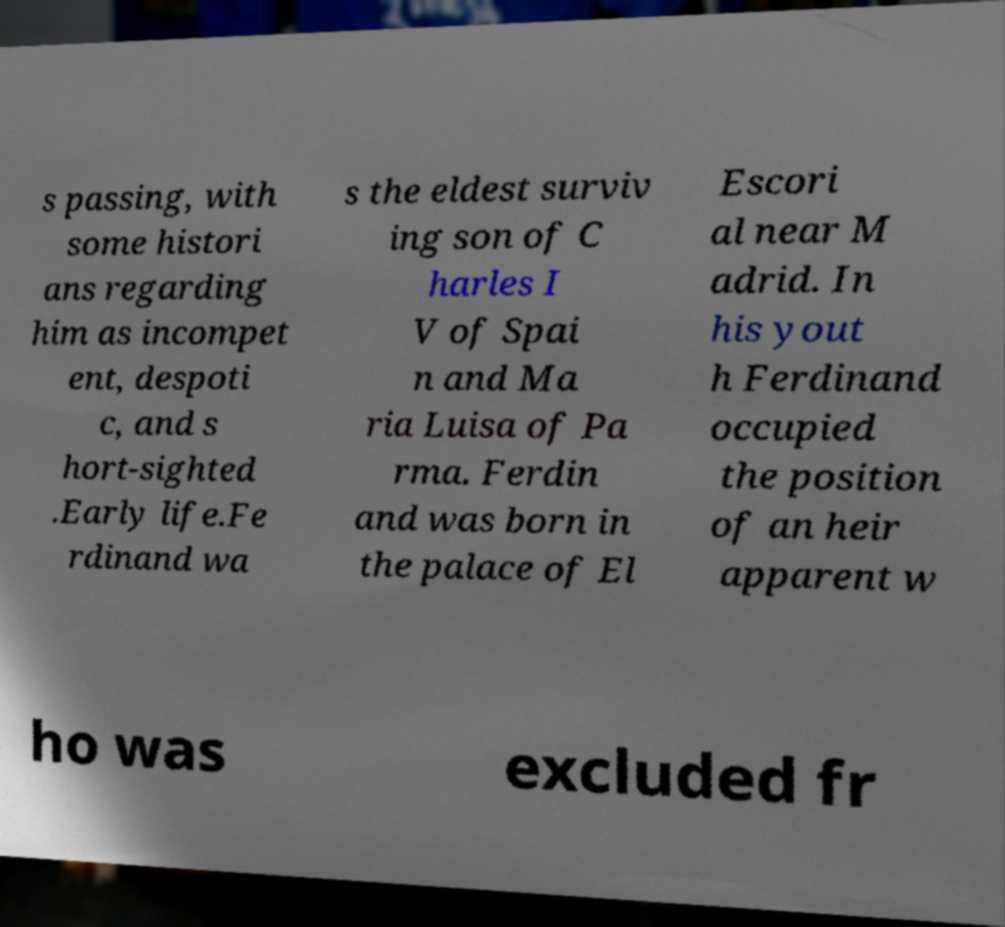Could you extract and type out the text from this image? s passing, with some histori ans regarding him as incompet ent, despoti c, and s hort-sighted .Early life.Fe rdinand wa s the eldest surviv ing son of C harles I V of Spai n and Ma ria Luisa of Pa rma. Ferdin and was born in the palace of El Escori al near M adrid. In his yout h Ferdinand occupied the position of an heir apparent w ho was excluded fr 